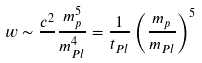<formula> <loc_0><loc_0><loc_500><loc_500>w \sim \frac { c ^ { 2 } } { } \frac { m _ { p } ^ { 5 } } { m _ { P l } ^ { 4 } } = \frac { 1 } { t _ { P l } } \left ( \frac { m _ { p } } { m _ { P l } } \right ) ^ { 5 }</formula> 